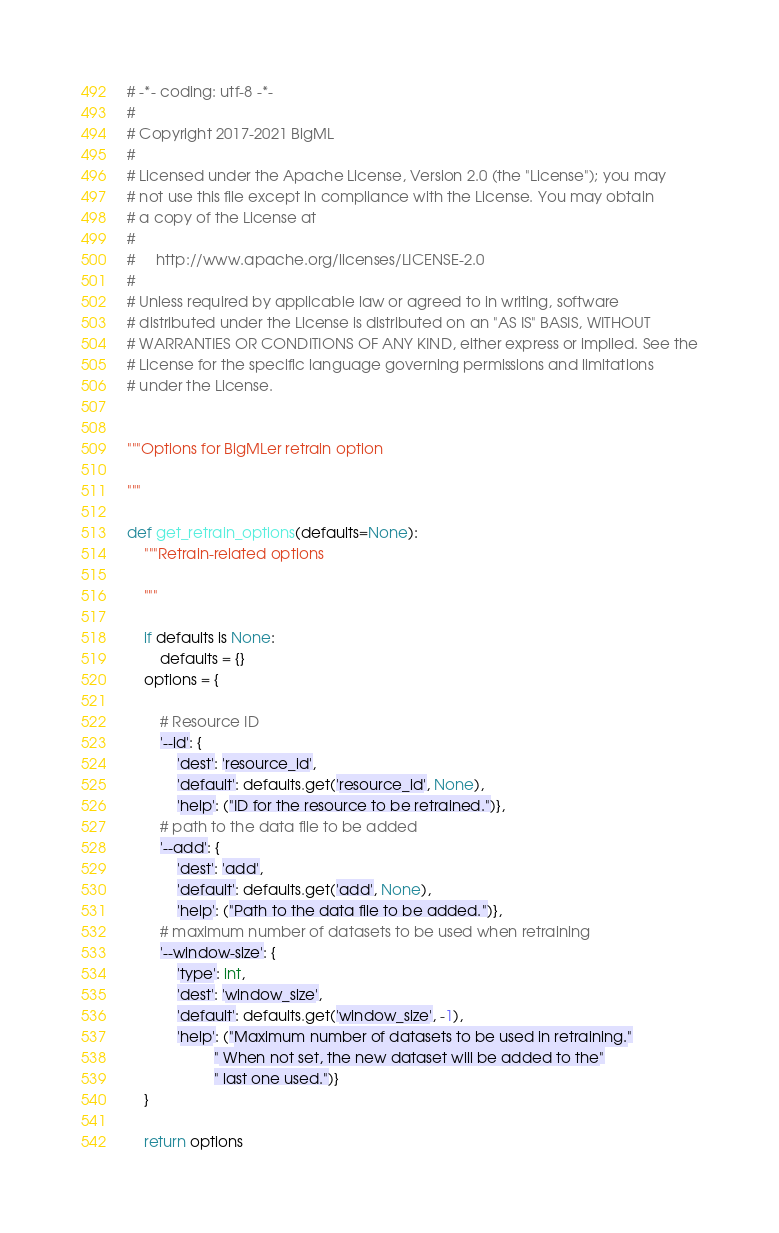<code> <loc_0><loc_0><loc_500><loc_500><_Python_># -*- coding: utf-8 -*-
#
# Copyright 2017-2021 BigML
#
# Licensed under the Apache License, Version 2.0 (the "License"); you may
# not use this file except in compliance with the License. You may obtain
# a copy of the License at
#
#     http://www.apache.org/licenses/LICENSE-2.0
#
# Unless required by applicable law or agreed to in writing, software
# distributed under the License is distributed on an "AS IS" BASIS, WITHOUT
# WARRANTIES OR CONDITIONS OF ANY KIND, either express or implied. See the
# License for the specific language governing permissions and limitations
# under the License.


"""Options for BigMLer retrain option

"""

def get_retrain_options(defaults=None):
    """Retrain-related options

    """

    if defaults is None:
        defaults = {}
    options = {

        # Resource ID
        '--id': {
            'dest': 'resource_id',
            'default': defaults.get('resource_id', None),
            'help': ("ID for the resource to be retrained.")},
        # path to the data file to be added
        '--add': {
            'dest': 'add',
            'default': defaults.get('add', None),
            'help': ("Path to the data file to be added.")},
        # maximum number of datasets to be used when retraining
        '--window-size': {
            'type': int,
            'dest': 'window_size',
            'default': defaults.get('window_size', -1),
            'help': ("Maximum number of datasets to be used in retraining."
                     " When not set, the new dataset will be added to the"
                     " last one used.")}
    }

    return options
</code> 